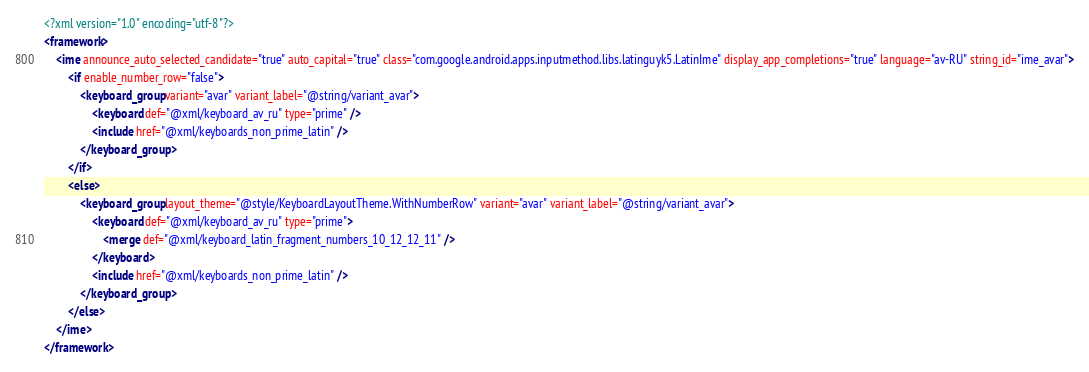Convert code to text. <code><loc_0><loc_0><loc_500><loc_500><_XML_><?xml version="1.0" encoding="utf-8"?>
<framework>
    <ime announce_auto_selected_candidate="true" auto_capital="true" class="com.google.android.apps.inputmethod.libs.latinguyk5.LatinIme" display_app_completions="true" language="av-RU" string_id="ime_avar">
        <if enable_number_row="false">
            <keyboard_group variant="avar" variant_label="@string/variant_avar">
                <keyboard def="@xml/keyboard_av_ru" type="prime" />
                <include href="@xml/keyboards_non_prime_latin" />
            </keyboard_group>
        </if>
        <else>
            <keyboard_group layout_theme="@style/KeyboardLayoutTheme.WithNumberRow" variant="avar" variant_label="@string/variant_avar">
                <keyboard def="@xml/keyboard_av_ru" type="prime">
                    <merge def="@xml/keyboard_latin_fragment_numbers_10_12_12_11" />
                </keyboard>
                <include href="@xml/keyboards_non_prime_latin" />
            </keyboard_group>
        </else>
    </ime>
</framework></code> 